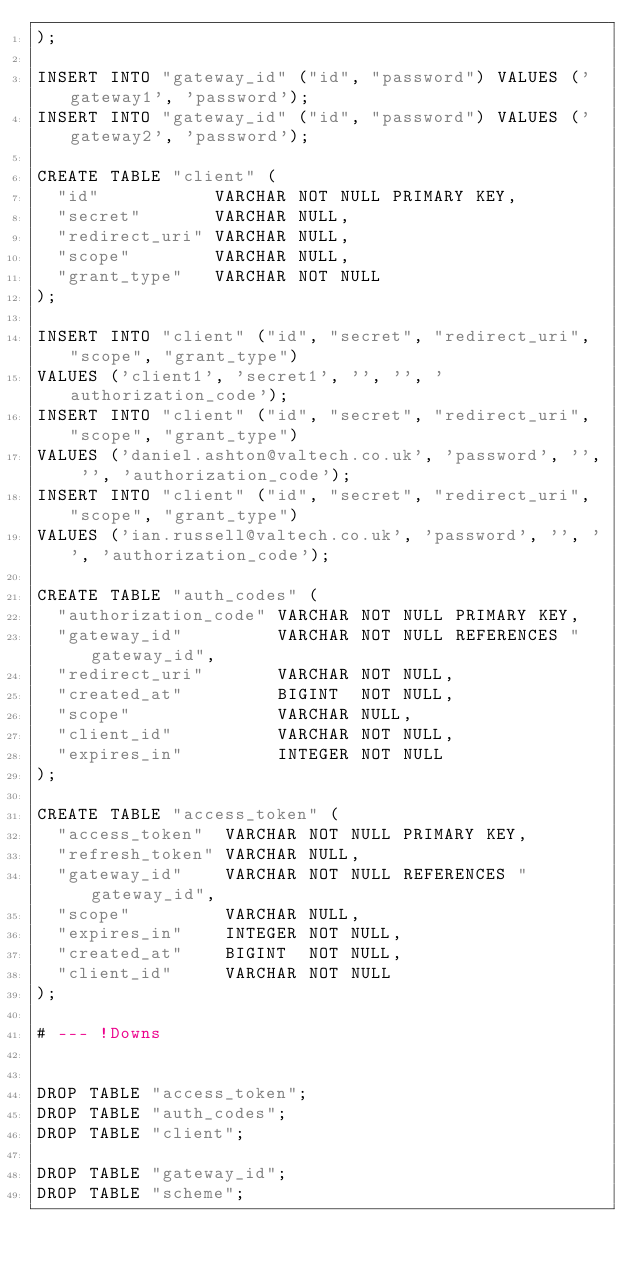<code> <loc_0><loc_0><loc_500><loc_500><_SQL_>);

INSERT INTO "gateway_id" ("id", "password") VALUES ('gateway1', 'password');
INSERT INTO "gateway_id" ("id", "password") VALUES ('gateway2', 'password');

CREATE TABLE "client" (
  "id"           VARCHAR NOT NULL PRIMARY KEY,
  "secret"       VARCHAR NULL,
  "redirect_uri" VARCHAR NULL,
  "scope"        VARCHAR NULL,
  "grant_type"   VARCHAR NOT NULL
);

INSERT INTO "client" ("id", "secret", "redirect_uri", "scope", "grant_type")
VALUES ('client1', 'secret1', '', '', 'authorization_code');
INSERT INTO "client" ("id", "secret", "redirect_uri", "scope", "grant_type")
VALUES ('daniel.ashton@valtech.co.uk', 'password', '', '', 'authorization_code');
INSERT INTO "client" ("id", "secret", "redirect_uri", "scope", "grant_type")
VALUES ('ian.russell@valtech.co.uk', 'password', '', '', 'authorization_code');

CREATE TABLE "auth_codes" (
  "authorization_code" VARCHAR NOT NULL PRIMARY KEY,
  "gateway_id"         VARCHAR NOT NULL REFERENCES "gateway_id",
  "redirect_uri"       VARCHAR NOT NULL,
  "created_at"         BIGINT  NOT NULL,
  "scope"              VARCHAR NULL,
  "client_id"          VARCHAR NOT NULL,
  "expires_in"         INTEGER NOT NULL
);

CREATE TABLE "access_token" (
  "access_token"  VARCHAR NOT NULL PRIMARY KEY,
  "refresh_token" VARCHAR NULL,
  "gateway_id"    VARCHAR NOT NULL REFERENCES "gateway_id",
  "scope"         VARCHAR NULL,
  "expires_in"    INTEGER NOT NULL,
  "created_at"    BIGINT  NOT NULL,
  "client_id"     VARCHAR NOT NULL
);

# --- !Downs


DROP TABLE "access_token";
DROP TABLE "auth_codes";
DROP TABLE "client";

DROP TABLE "gateway_id";
DROP TABLE "scheme";
</code> 